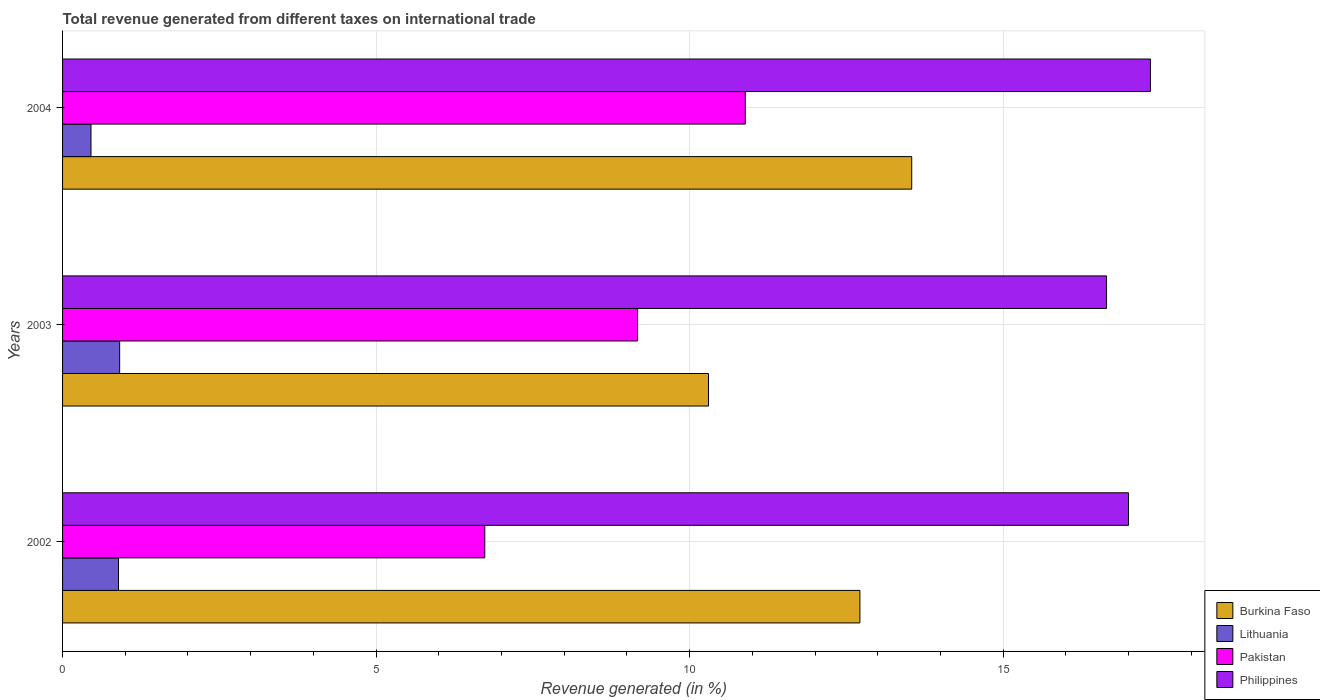How many different coloured bars are there?
Keep it short and to the point. 4. How many groups of bars are there?
Provide a short and direct response. 3. What is the label of the 2nd group of bars from the top?
Keep it short and to the point. 2003. In how many cases, is the number of bars for a given year not equal to the number of legend labels?
Provide a short and direct response. 0. What is the total revenue generated in Burkina Faso in 2002?
Provide a short and direct response. 12.71. Across all years, what is the maximum total revenue generated in Philippines?
Your answer should be compact. 17.35. Across all years, what is the minimum total revenue generated in Philippines?
Keep it short and to the point. 16.65. In which year was the total revenue generated in Burkina Faso minimum?
Give a very brief answer. 2003. What is the total total revenue generated in Lithuania in the graph?
Offer a very short reply. 2.26. What is the difference between the total revenue generated in Philippines in 2003 and that in 2004?
Offer a terse response. -0.7. What is the difference between the total revenue generated in Philippines in 2004 and the total revenue generated in Lithuania in 2002?
Ensure brevity in your answer.  16.46. What is the average total revenue generated in Philippines per year?
Your answer should be compact. 17. In the year 2002, what is the difference between the total revenue generated in Pakistan and total revenue generated in Philippines?
Provide a succinct answer. -10.27. What is the ratio of the total revenue generated in Philippines in 2002 to that in 2004?
Provide a short and direct response. 0.98. What is the difference between the highest and the second highest total revenue generated in Burkina Faso?
Give a very brief answer. 0.83. What is the difference between the highest and the lowest total revenue generated in Philippines?
Keep it short and to the point. 0.7. Is the sum of the total revenue generated in Lithuania in 2003 and 2004 greater than the maximum total revenue generated in Philippines across all years?
Give a very brief answer. No. Is it the case that in every year, the sum of the total revenue generated in Pakistan and total revenue generated in Burkina Faso is greater than the sum of total revenue generated in Philippines and total revenue generated in Lithuania?
Your response must be concise. No. What does the 3rd bar from the bottom in 2004 represents?
Provide a short and direct response. Pakistan. Is it the case that in every year, the sum of the total revenue generated in Burkina Faso and total revenue generated in Philippines is greater than the total revenue generated in Pakistan?
Provide a short and direct response. Yes. Are all the bars in the graph horizontal?
Your answer should be compact. Yes. Does the graph contain any zero values?
Make the answer very short. No. Where does the legend appear in the graph?
Make the answer very short. Bottom right. How are the legend labels stacked?
Your response must be concise. Vertical. What is the title of the graph?
Keep it short and to the point. Total revenue generated from different taxes on international trade. Does "Tanzania" appear as one of the legend labels in the graph?
Your answer should be compact. No. What is the label or title of the X-axis?
Offer a very short reply. Revenue generated (in %). What is the label or title of the Y-axis?
Make the answer very short. Years. What is the Revenue generated (in %) of Burkina Faso in 2002?
Ensure brevity in your answer.  12.71. What is the Revenue generated (in %) in Lithuania in 2002?
Provide a short and direct response. 0.89. What is the Revenue generated (in %) in Pakistan in 2002?
Provide a succinct answer. 6.73. What is the Revenue generated (in %) of Philippines in 2002?
Keep it short and to the point. 17. What is the Revenue generated (in %) in Burkina Faso in 2003?
Give a very brief answer. 10.3. What is the Revenue generated (in %) in Lithuania in 2003?
Offer a terse response. 0.91. What is the Revenue generated (in %) of Pakistan in 2003?
Ensure brevity in your answer.  9.17. What is the Revenue generated (in %) of Philippines in 2003?
Provide a succinct answer. 16.65. What is the Revenue generated (in %) in Burkina Faso in 2004?
Offer a very short reply. 13.54. What is the Revenue generated (in %) in Lithuania in 2004?
Keep it short and to the point. 0.45. What is the Revenue generated (in %) in Pakistan in 2004?
Your answer should be very brief. 10.89. What is the Revenue generated (in %) in Philippines in 2004?
Ensure brevity in your answer.  17.35. Across all years, what is the maximum Revenue generated (in %) in Burkina Faso?
Give a very brief answer. 13.54. Across all years, what is the maximum Revenue generated (in %) in Lithuania?
Keep it short and to the point. 0.91. Across all years, what is the maximum Revenue generated (in %) in Pakistan?
Provide a succinct answer. 10.89. Across all years, what is the maximum Revenue generated (in %) of Philippines?
Ensure brevity in your answer.  17.35. Across all years, what is the minimum Revenue generated (in %) in Burkina Faso?
Provide a short and direct response. 10.3. Across all years, what is the minimum Revenue generated (in %) of Lithuania?
Your answer should be very brief. 0.45. Across all years, what is the minimum Revenue generated (in %) in Pakistan?
Ensure brevity in your answer.  6.73. Across all years, what is the minimum Revenue generated (in %) of Philippines?
Provide a succinct answer. 16.65. What is the total Revenue generated (in %) in Burkina Faso in the graph?
Offer a terse response. 36.56. What is the total Revenue generated (in %) in Lithuania in the graph?
Ensure brevity in your answer.  2.26. What is the total Revenue generated (in %) of Pakistan in the graph?
Your answer should be compact. 26.79. What is the total Revenue generated (in %) of Philippines in the graph?
Provide a succinct answer. 50.99. What is the difference between the Revenue generated (in %) of Burkina Faso in 2002 and that in 2003?
Provide a succinct answer. 2.41. What is the difference between the Revenue generated (in %) of Lithuania in 2002 and that in 2003?
Give a very brief answer. -0.02. What is the difference between the Revenue generated (in %) in Pakistan in 2002 and that in 2003?
Keep it short and to the point. -2.44. What is the difference between the Revenue generated (in %) in Philippines in 2002 and that in 2003?
Offer a terse response. 0.35. What is the difference between the Revenue generated (in %) of Burkina Faso in 2002 and that in 2004?
Keep it short and to the point. -0.83. What is the difference between the Revenue generated (in %) in Lithuania in 2002 and that in 2004?
Ensure brevity in your answer.  0.44. What is the difference between the Revenue generated (in %) of Pakistan in 2002 and that in 2004?
Keep it short and to the point. -4.15. What is the difference between the Revenue generated (in %) of Philippines in 2002 and that in 2004?
Your answer should be very brief. -0.35. What is the difference between the Revenue generated (in %) of Burkina Faso in 2003 and that in 2004?
Provide a succinct answer. -3.24. What is the difference between the Revenue generated (in %) in Lithuania in 2003 and that in 2004?
Make the answer very short. 0.46. What is the difference between the Revenue generated (in %) of Pakistan in 2003 and that in 2004?
Make the answer very short. -1.72. What is the difference between the Revenue generated (in %) of Philippines in 2003 and that in 2004?
Keep it short and to the point. -0.7. What is the difference between the Revenue generated (in %) of Burkina Faso in 2002 and the Revenue generated (in %) of Lithuania in 2003?
Offer a terse response. 11.8. What is the difference between the Revenue generated (in %) in Burkina Faso in 2002 and the Revenue generated (in %) in Pakistan in 2003?
Provide a succinct answer. 3.55. What is the difference between the Revenue generated (in %) of Burkina Faso in 2002 and the Revenue generated (in %) of Philippines in 2003?
Your answer should be very brief. -3.93. What is the difference between the Revenue generated (in %) in Lithuania in 2002 and the Revenue generated (in %) in Pakistan in 2003?
Give a very brief answer. -8.28. What is the difference between the Revenue generated (in %) in Lithuania in 2002 and the Revenue generated (in %) in Philippines in 2003?
Keep it short and to the point. -15.76. What is the difference between the Revenue generated (in %) in Pakistan in 2002 and the Revenue generated (in %) in Philippines in 2003?
Provide a succinct answer. -9.92. What is the difference between the Revenue generated (in %) in Burkina Faso in 2002 and the Revenue generated (in %) in Lithuania in 2004?
Keep it short and to the point. 12.26. What is the difference between the Revenue generated (in %) of Burkina Faso in 2002 and the Revenue generated (in %) of Pakistan in 2004?
Ensure brevity in your answer.  1.83. What is the difference between the Revenue generated (in %) in Burkina Faso in 2002 and the Revenue generated (in %) in Philippines in 2004?
Make the answer very short. -4.63. What is the difference between the Revenue generated (in %) in Lithuania in 2002 and the Revenue generated (in %) in Pakistan in 2004?
Ensure brevity in your answer.  -9.99. What is the difference between the Revenue generated (in %) in Lithuania in 2002 and the Revenue generated (in %) in Philippines in 2004?
Offer a terse response. -16.46. What is the difference between the Revenue generated (in %) in Pakistan in 2002 and the Revenue generated (in %) in Philippines in 2004?
Ensure brevity in your answer.  -10.62. What is the difference between the Revenue generated (in %) in Burkina Faso in 2003 and the Revenue generated (in %) in Lithuania in 2004?
Give a very brief answer. 9.85. What is the difference between the Revenue generated (in %) in Burkina Faso in 2003 and the Revenue generated (in %) in Pakistan in 2004?
Offer a very short reply. -0.59. What is the difference between the Revenue generated (in %) of Burkina Faso in 2003 and the Revenue generated (in %) of Philippines in 2004?
Offer a terse response. -7.05. What is the difference between the Revenue generated (in %) in Lithuania in 2003 and the Revenue generated (in %) in Pakistan in 2004?
Your answer should be compact. -9.98. What is the difference between the Revenue generated (in %) of Lithuania in 2003 and the Revenue generated (in %) of Philippines in 2004?
Offer a terse response. -16.44. What is the difference between the Revenue generated (in %) in Pakistan in 2003 and the Revenue generated (in %) in Philippines in 2004?
Provide a succinct answer. -8.18. What is the average Revenue generated (in %) in Burkina Faso per year?
Make the answer very short. 12.19. What is the average Revenue generated (in %) in Lithuania per year?
Give a very brief answer. 0.75. What is the average Revenue generated (in %) in Pakistan per year?
Provide a succinct answer. 8.93. What is the average Revenue generated (in %) of Philippines per year?
Your answer should be compact. 17. In the year 2002, what is the difference between the Revenue generated (in %) in Burkina Faso and Revenue generated (in %) in Lithuania?
Keep it short and to the point. 11.82. In the year 2002, what is the difference between the Revenue generated (in %) in Burkina Faso and Revenue generated (in %) in Pakistan?
Make the answer very short. 5.98. In the year 2002, what is the difference between the Revenue generated (in %) in Burkina Faso and Revenue generated (in %) in Philippines?
Offer a very short reply. -4.28. In the year 2002, what is the difference between the Revenue generated (in %) of Lithuania and Revenue generated (in %) of Pakistan?
Ensure brevity in your answer.  -5.84. In the year 2002, what is the difference between the Revenue generated (in %) of Lithuania and Revenue generated (in %) of Philippines?
Your answer should be compact. -16.11. In the year 2002, what is the difference between the Revenue generated (in %) in Pakistan and Revenue generated (in %) in Philippines?
Keep it short and to the point. -10.27. In the year 2003, what is the difference between the Revenue generated (in %) of Burkina Faso and Revenue generated (in %) of Lithuania?
Make the answer very short. 9.39. In the year 2003, what is the difference between the Revenue generated (in %) of Burkina Faso and Revenue generated (in %) of Pakistan?
Ensure brevity in your answer.  1.13. In the year 2003, what is the difference between the Revenue generated (in %) in Burkina Faso and Revenue generated (in %) in Philippines?
Your answer should be very brief. -6.35. In the year 2003, what is the difference between the Revenue generated (in %) in Lithuania and Revenue generated (in %) in Pakistan?
Offer a very short reply. -8.26. In the year 2003, what is the difference between the Revenue generated (in %) in Lithuania and Revenue generated (in %) in Philippines?
Make the answer very short. -15.74. In the year 2003, what is the difference between the Revenue generated (in %) of Pakistan and Revenue generated (in %) of Philippines?
Provide a short and direct response. -7.48. In the year 2004, what is the difference between the Revenue generated (in %) of Burkina Faso and Revenue generated (in %) of Lithuania?
Give a very brief answer. 13.09. In the year 2004, what is the difference between the Revenue generated (in %) in Burkina Faso and Revenue generated (in %) in Pakistan?
Give a very brief answer. 2.65. In the year 2004, what is the difference between the Revenue generated (in %) in Burkina Faso and Revenue generated (in %) in Philippines?
Offer a terse response. -3.81. In the year 2004, what is the difference between the Revenue generated (in %) in Lithuania and Revenue generated (in %) in Pakistan?
Your response must be concise. -10.43. In the year 2004, what is the difference between the Revenue generated (in %) in Lithuania and Revenue generated (in %) in Philippines?
Give a very brief answer. -16.89. In the year 2004, what is the difference between the Revenue generated (in %) in Pakistan and Revenue generated (in %) in Philippines?
Give a very brief answer. -6.46. What is the ratio of the Revenue generated (in %) in Burkina Faso in 2002 to that in 2003?
Give a very brief answer. 1.23. What is the ratio of the Revenue generated (in %) in Lithuania in 2002 to that in 2003?
Offer a very short reply. 0.98. What is the ratio of the Revenue generated (in %) in Pakistan in 2002 to that in 2003?
Provide a succinct answer. 0.73. What is the ratio of the Revenue generated (in %) of Philippines in 2002 to that in 2003?
Provide a short and direct response. 1.02. What is the ratio of the Revenue generated (in %) of Burkina Faso in 2002 to that in 2004?
Your response must be concise. 0.94. What is the ratio of the Revenue generated (in %) in Lithuania in 2002 to that in 2004?
Ensure brevity in your answer.  1.97. What is the ratio of the Revenue generated (in %) in Pakistan in 2002 to that in 2004?
Offer a very short reply. 0.62. What is the ratio of the Revenue generated (in %) of Philippines in 2002 to that in 2004?
Provide a short and direct response. 0.98. What is the ratio of the Revenue generated (in %) in Burkina Faso in 2003 to that in 2004?
Provide a succinct answer. 0.76. What is the ratio of the Revenue generated (in %) in Lithuania in 2003 to that in 2004?
Your answer should be very brief. 2.01. What is the ratio of the Revenue generated (in %) of Pakistan in 2003 to that in 2004?
Your answer should be very brief. 0.84. What is the ratio of the Revenue generated (in %) of Philippines in 2003 to that in 2004?
Provide a short and direct response. 0.96. What is the difference between the highest and the second highest Revenue generated (in %) of Burkina Faso?
Make the answer very short. 0.83. What is the difference between the highest and the second highest Revenue generated (in %) of Lithuania?
Ensure brevity in your answer.  0.02. What is the difference between the highest and the second highest Revenue generated (in %) of Pakistan?
Make the answer very short. 1.72. What is the difference between the highest and the second highest Revenue generated (in %) of Philippines?
Your answer should be very brief. 0.35. What is the difference between the highest and the lowest Revenue generated (in %) of Burkina Faso?
Your answer should be compact. 3.24. What is the difference between the highest and the lowest Revenue generated (in %) in Lithuania?
Offer a very short reply. 0.46. What is the difference between the highest and the lowest Revenue generated (in %) in Pakistan?
Offer a very short reply. 4.15. 